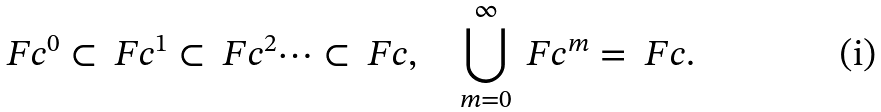Convert formula to latex. <formula><loc_0><loc_0><loc_500><loc_500>\ F c ^ { 0 } \subset \ F c ^ { 1 } \subset \ F c ^ { 2 } \dots \subset \ F c , \quad \bigcup _ { m = 0 } ^ { \infty } \ F c ^ { m } = \ F c .</formula> 